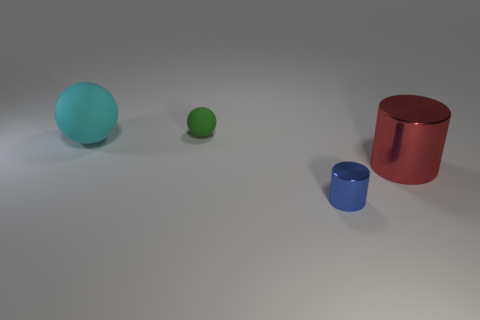Add 2 cyan balls. How many objects exist? 6 Add 1 tiny blue things. How many tiny blue things are left? 2 Add 4 yellow shiny balls. How many yellow shiny balls exist? 4 Subtract 0 cyan cubes. How many objects are left? 4 Subtract all green spheres. Subtract all small rubber spheres. How many objects are left? 2 